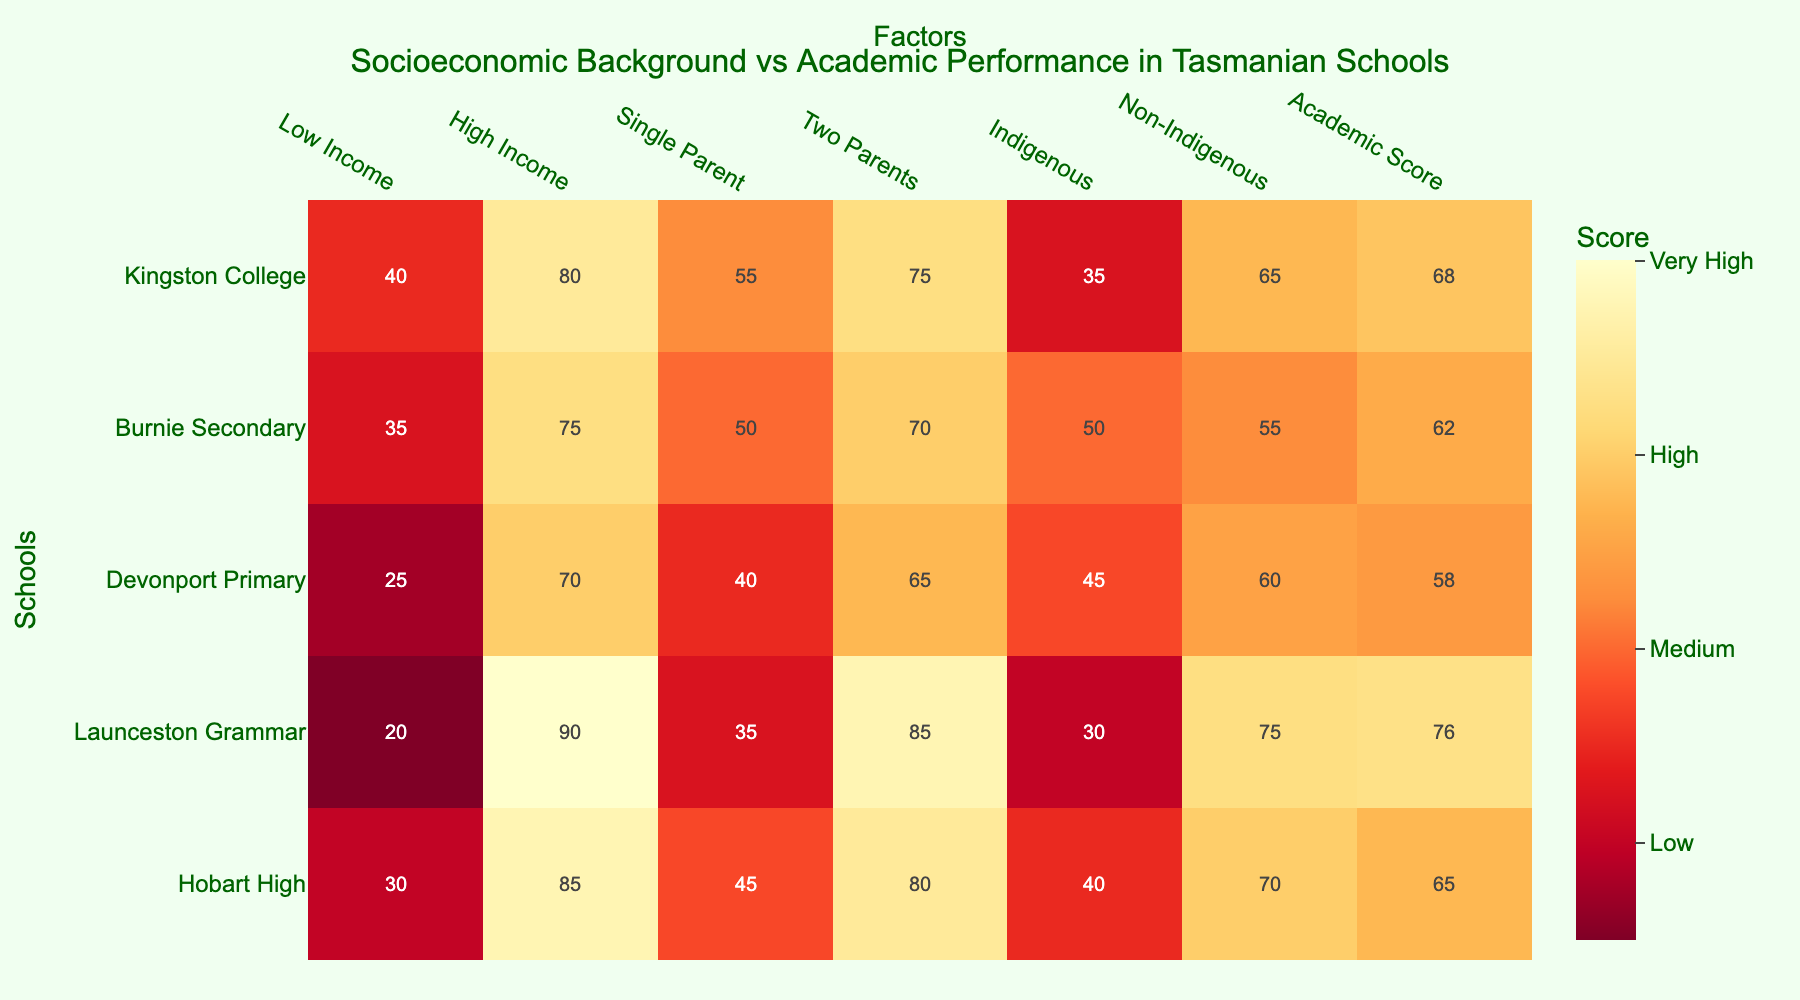Which school has the highest academic score? Look for the highest value in the "Academic Score" column on the rightmost side of the heatmap and identify the corresponding school on the y-axis.
Answer: Launceston Grammar What's the average academic score across all the listed schools? Add up all the values in the "Academic Score" column (65 + 76 + 58 + 62 + 68) and then divide by the number of schools (5). (65 + 76 + 58 + 62 + 68) / 5 = 329 / 5 = 65.8
Answer: 65.8 Which school has the highest proportion of students from low-income backgrounds? Look for the highest value in the "Low Income" column and identify the corresponding school.
Answer: Kingston College How does the academic score of Hobart High compare to Burnie Secondary? Find the academic scores for both schools and compare them. Hobart High has a score of 65 and Burnie Secondary has a score of 62, so Hobart High has a higher score.
Answer: Hobart High is higher What's the difference in the proportion of students from single-parent backgrounds between Devonport Primary and Hobart High? Find the values for single-parent backgrounds for both schools (Devonport Primary: 40, Hobart High: 45). The difference is 45 - 40 = 5.
Answer: 5 Is there a school where the proportion of single-parent students is equal to the proportion of high-income students? Check the values in the columns "Single Parent" and "High Income" for any school where these two numbers match. No school has matching values for these two columns.
Answer: No Which school has the lowest proportion of students from indigenous backgrounds? Find the lowest value in the "Indigenous" column and identify the corresponding school.
Answer: Launceston Grammar What is the correlation between 'High Income' and 'Academic Score' as observed in the heatmap? Look for patterns in the heatmap's colors between "High Income" and "Academic Score" columns to assess if higher income appears to correlate with higher academic scores. From visual inspection, higher income seems related to higher academic scores.
Answer: Positive correlation Do any schools have a higher proportion of students from two-parent backgrounds than from non-indigenous backgrounds? Compare the values in the "Two Parents" and "Non-Indigenous" columns for each school.
Answer: Launceston Grammar, Kingston College Which school has the most balanced representation across all socioeconomic factors? Assess each school's values visually to see which has close values across all categories.
Answer: Launceston Grammar 